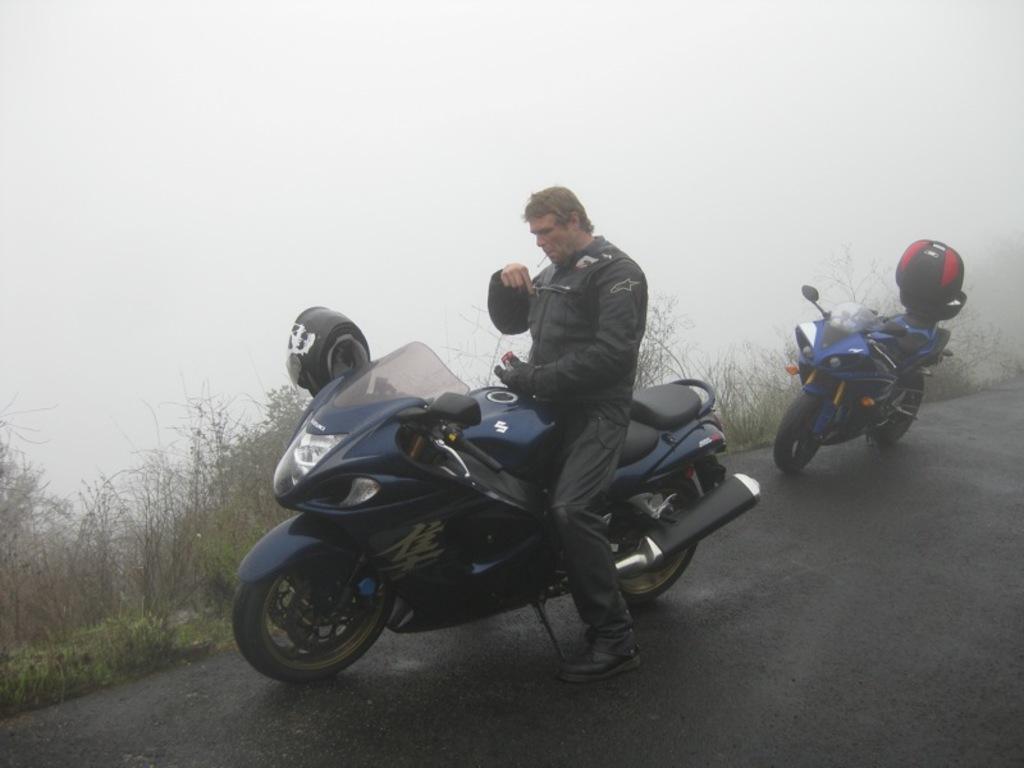In one or two sentences, can you explain what this image depicts? a person is standing on a motorcycle. behind him there is another blue motorcycle, at its back there is a helmet. behind them them there are plants and fog. 